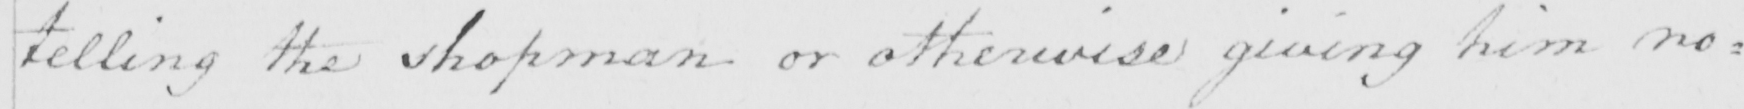Transcribe the text shown in this historical manuscript line. telling the shopman or otherwise giving him no : 